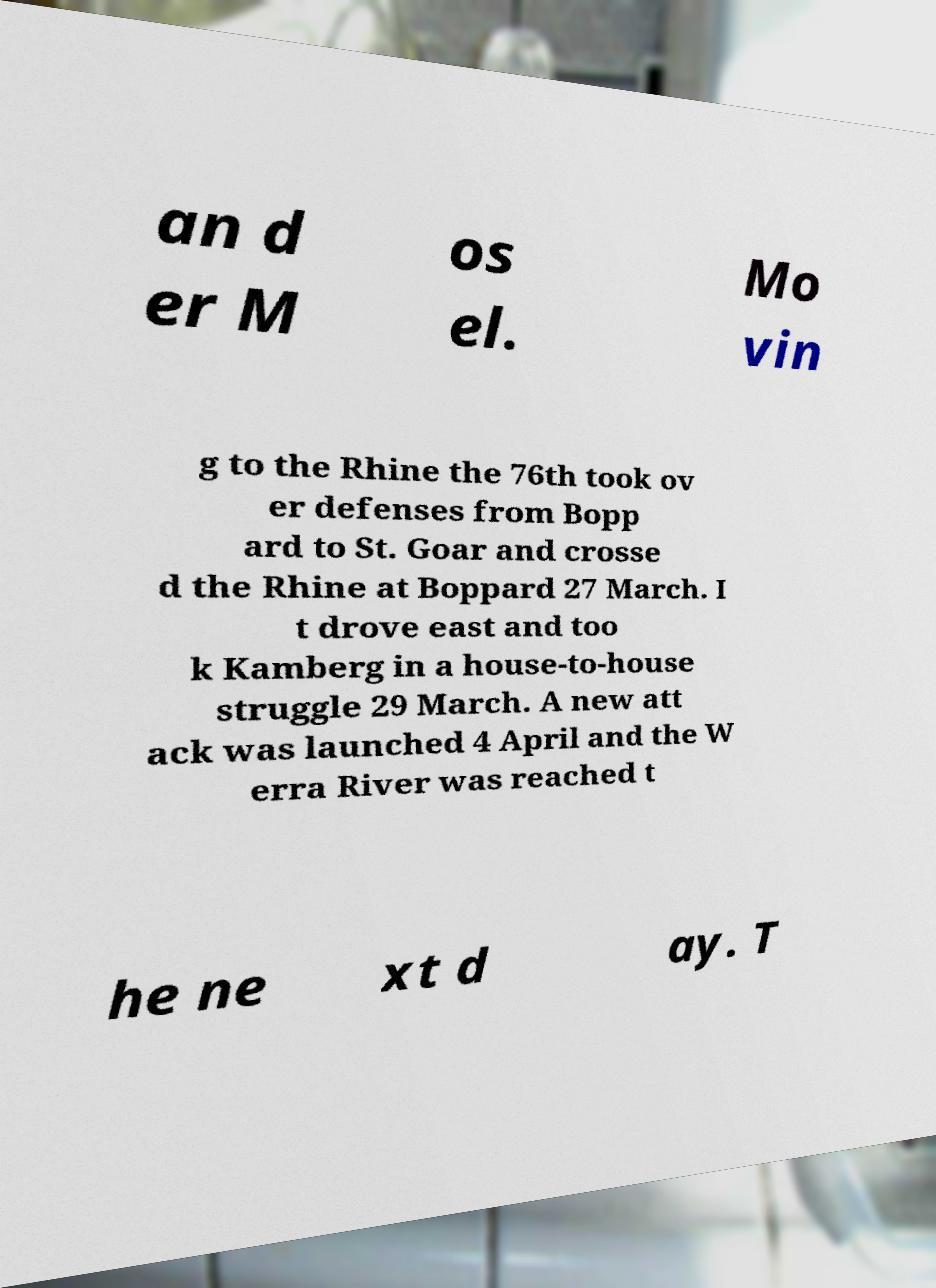There's text embedded in this image that I need extracted. Can you transcribe it verbatim? an d er M os el. Mo vin g to the Rhine the 76th took ov er defenses from Bopp ard to St. Goar and crosse d the Rhine at Boppard 27 March. I t drove east and too k Kamberg in a house-to-house struggle 29 March. A new att ack was launched 4 April and the W erra River was reached t he ne xt d ay. T 